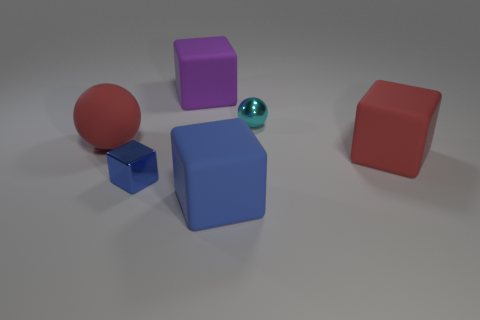Is the color of the small block the same as the matte cube in front of the small blue cube?
Keep it short and to the point. Yes. There is a big sphere; are there any blocks in front of it?
Keep it short and to the point. Yes. Is the material of the small cyan object the same as the large purple cube?
Offer a terse response. No. What is the material of the thing that is the same size as the metal block?
Your response must be concise. Metal. What number of objects are red rubber things that are right of the large blue block or large gray matte objects?
Your answer should be very brief. 1. Are there an equal number of rubber spheres that are to the left of the red matte sphere and large yellow rubber blocks?
Offer a very short reply. Yes. What color is the block that is behind the metal block and left of the small ball?
Give a very brief answer. Purple. What number of cylinders are either cyan objects or tiny blue metallic objects?
Your response must be concise. 0. Are there fewer blue shiny objects that are on the left side of the matte sphere than small purple matte spheres?
Provide a succinct answer. No. What is the shape of the big blue thing that is the same material as the large purple object?
Give a very brief answer. Cube. 